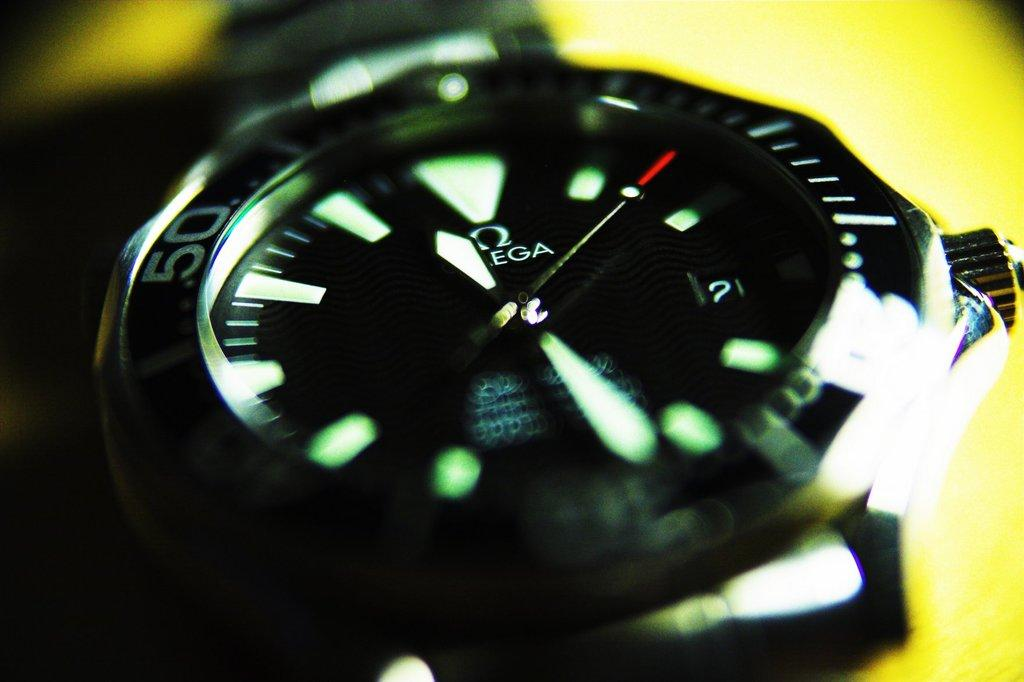<image>
Render a clear and concise summary of the photo. An Omega brand watch tells the time at a close proximity. 